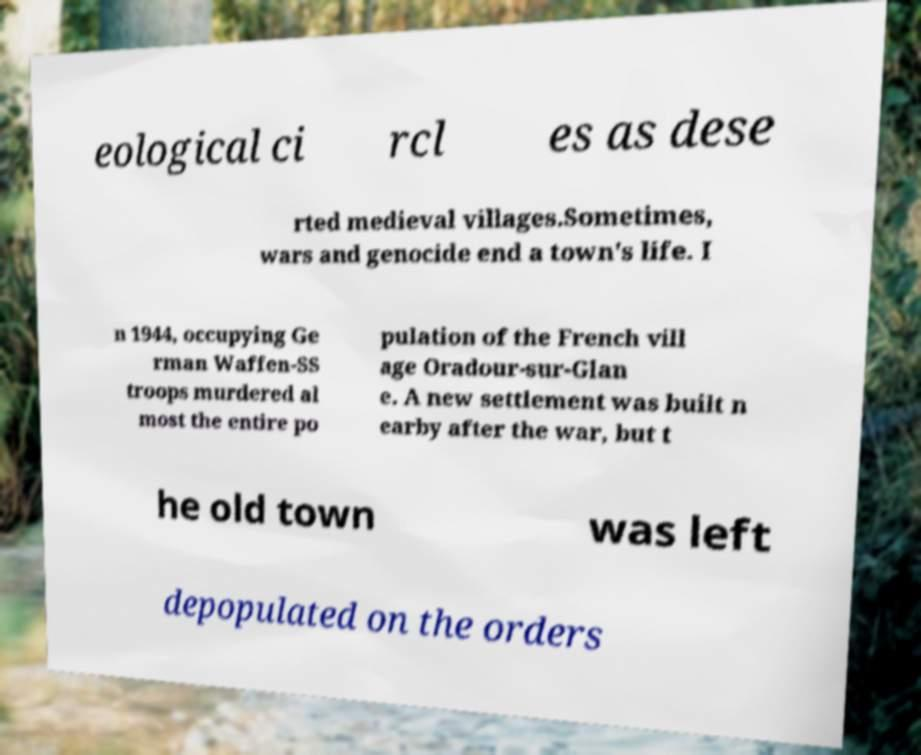Could you assist in decoding the text presented in this image and type it out clearly? eological ci rcl es as dese rted medieval villages.Sometimes, wars and genocide end a town's life. I n 1944, occupying Ge rman Waffen-SS troops murdered al most the entire po pulation of the French vill age Oradour-sur-Glan e. A new settlement was built n earby after the war, but t he old town was left depopulated on the orders 